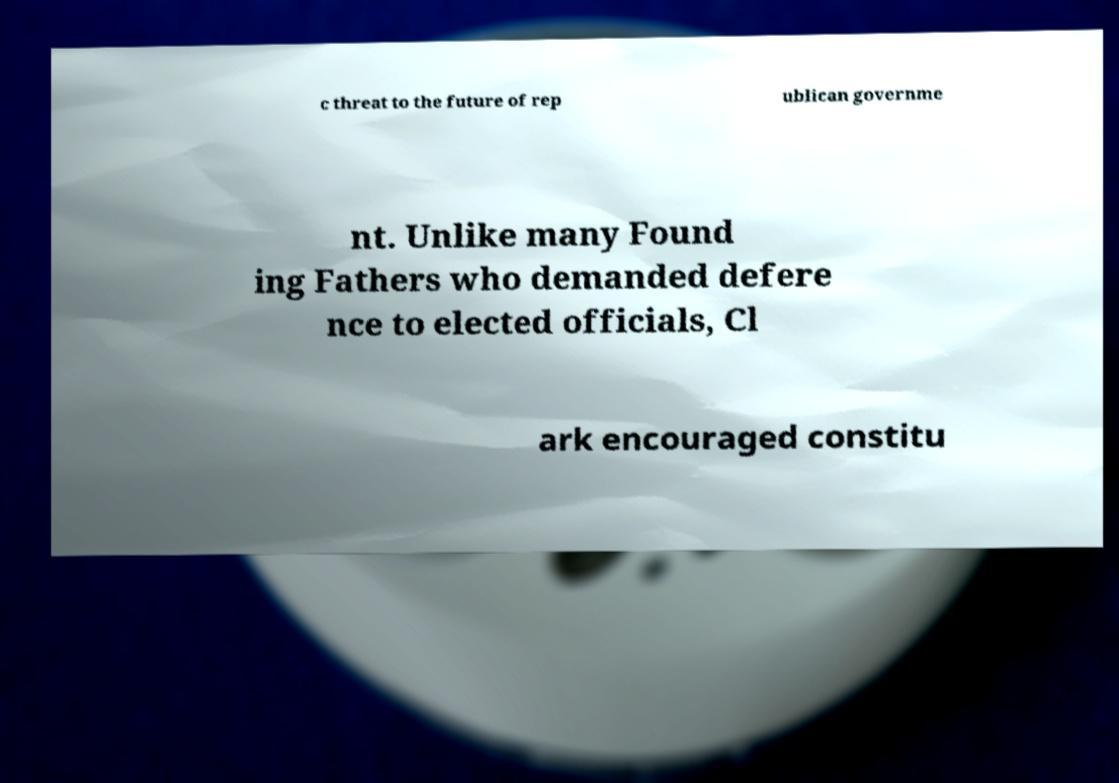Could you extract and type out the text from this image? c threat to the future of rep ublican governme nt. Unlike many Found ing Fathers who demanded defere nce to elected officials, Cl ark encouraged constitu 